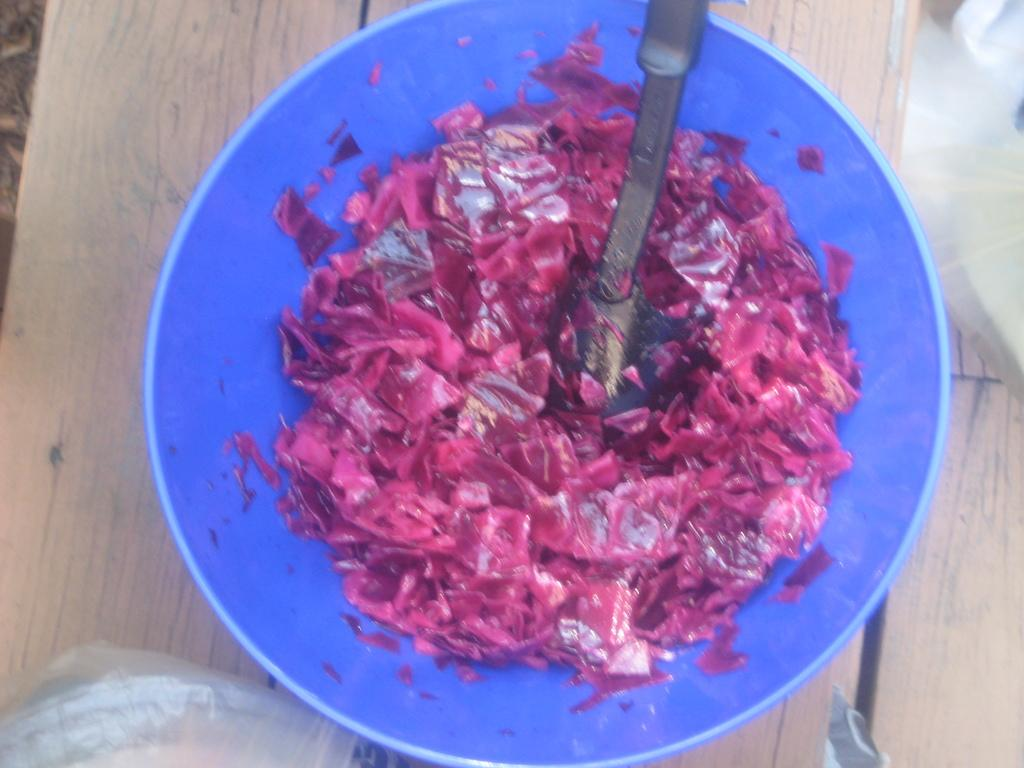What is in the bowl that is visible in the image? There is food in a bowl in the image. What type of surface is the bowl placed on? The bowl is placed on a wooden surface. What type of bulb is being used in the chess game in the image? There is no chess game or bulb present in the image. 